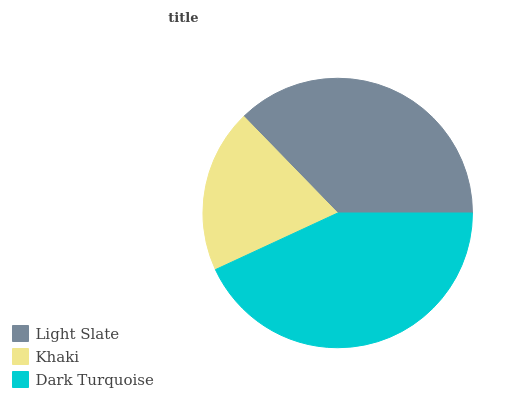Is Khaki the minimum?
Answer yes or no. Yes. Is Dark Turquoise the maximum?
Answer yes or no. Yes. Is Dark Turquoise the minimum?
Answer yes or no. No. Is Khaki the maximum?
Answer yes or no. No. Is Dark Turquoise greater than Khaki?
Answer yes or no. Yes. Is Khaki less than Dark Turquoise?
Answer yes or no. Yes. Is Khaki greater than Dark Turquoise?
Answer yes or no. No. Is Dark Turquoise less than Khaki?
Answer yes or no. No. Is Light Slate the high median?
Answer yes or no. Yes. Is Light Slate the low median?
Answer yes or no. Yes. Is Dark Turquoise the high median?
Answer yes or no. No. Is Dark Turquoise the low median?
Answer yes or no. No. 